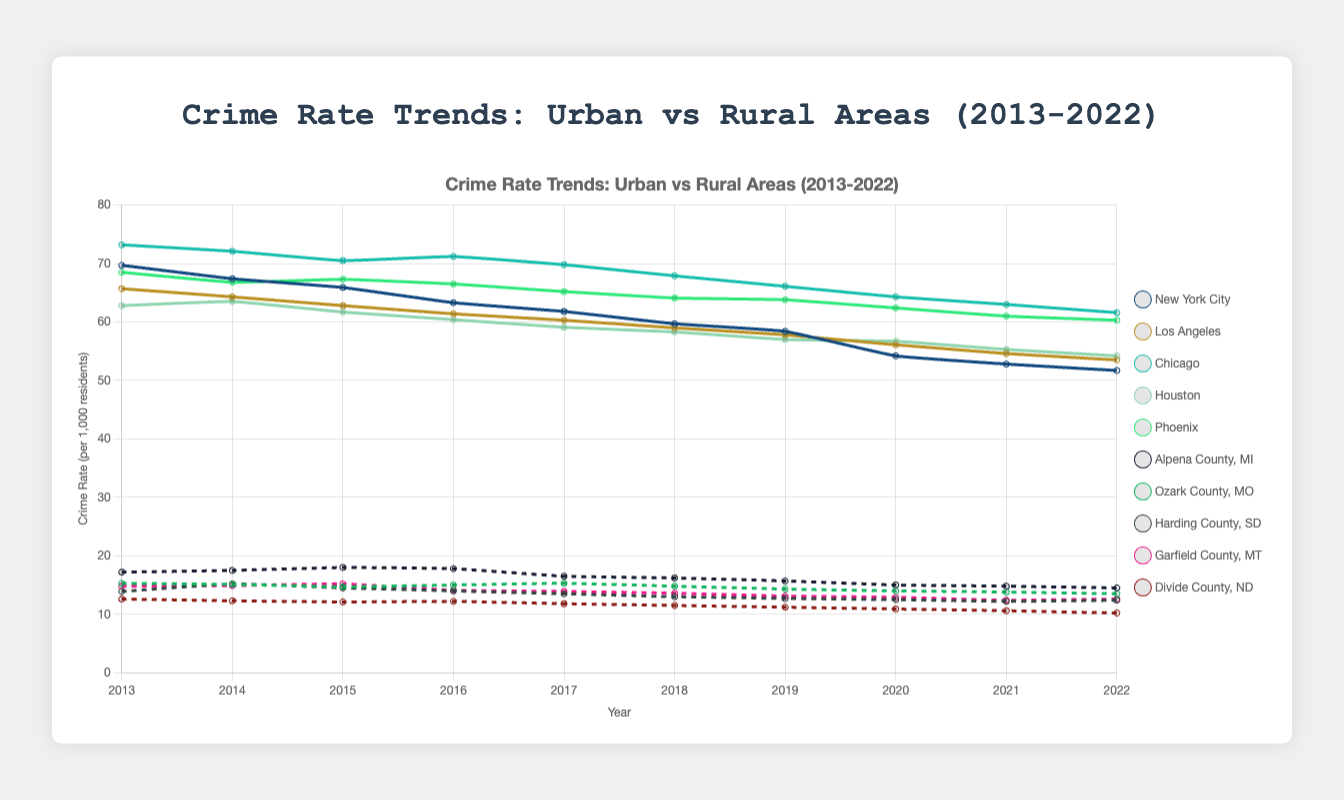What is the overall trend in the crime rates in urban areas over the past decade? The overall trend can be observed from the line plot representing the crime rates in urban areas from 2013 to 2022. By visually inspecting these lines, one can see that the crime rates in all listed urban areas (New York City, Los Angeles, Chicago, Houston, Phoenix) show a general decreasing trend over the decade.
Answer: Decreasing Which urban area had the highest crime rate in 2020? By looking at the data points for 2020 on the line plot, we can see that Chicago had the highest crime rate among the listed urban areas.
Answer: Chicago How do the crime rates in the urban area of New York City compare to those in the rural area of Alpena County, MI in 2016? We need to find the data points for New York City and Alpena County, MI in the year 2016. According to the plot, New York City's crime rate was approximately 63.3, whereas Alpena County, MI's crime rate was around 17.8. New York City's crime rate was significantly higher than Alpena County, MI's crime rate.
Answer: Higher What was the average crime rate in rural areas in 2019? To calculate the average crime rate for rural areas in 2019, we add the crime rates for all listed rural areas and then divide by the number of areas. (15.7 + 14.3 + 12.7 + 13.1 + 11.2) / 5 = 67 / 5.
Answer: 13.4 Which year did New York City experience the largest decrease in crime rate, compared to the previous year? By examining the plot lines for New York City, we can see the differences in crime rates between consecutive years. The largest decrease appears between 2019 (58.4) and 2020 (54.2), a decline of 4.2 points.
Answer: 2020 What is the difference in crime rates between the urban area with the lowest crime rate and the rural area with the highest crime rate in 2013? Looking at the plot for 2013, the urban area with the lowest crime rate is Houston (62.8), and the rural area with the highest crime rate is Alpena County, MI (17.2). The difference is 62.8 - 17.2.
Answer: 45.6 During which years did Harding County, SD see an increase in crime rate compared to the previous year? Reviewing the line plot for Harding County, SD, we can identify the years with increases by comparing the crime rate values of consecutive years. Harding County, SD saw increases from 13.9 in 2013 to 15.2 in 2014.
Answer: 2014 By how much did Phoenix's crime rate change from 2013 to 2022? We can find the crime rates for Phoenix in 2013 and 2022 on the plots, which are approximately 68.5 and 60.3, respectively. The change is 68.5 - 60.3 = 8.2 points.
Answer: 8.2 What was the peak crime rate in Los Angeles over the past decade, and in which year did it occur? Observing the line plot for Los Angeles, the highest point is around 65.7 in 2013.
Answer: 65.7, 2013 